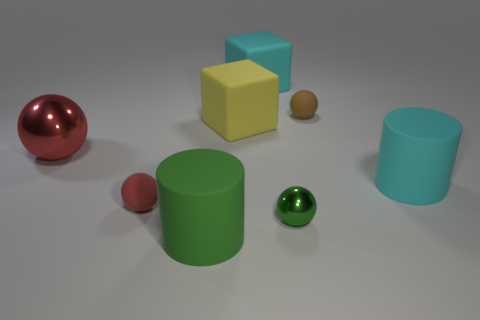Are there any other things that are the same color as the big ball?
Ensure brevity in your answer.  Yes. How many things are matte spheres that are in front of the big cyan rubber cylinder or big rubber cylinders that are right of the tiny brown thing?
Provide a short and direct response. 2. The object that is in front of the brown matte sphere and on the right side of the small metal ball has what shape?
Your answer should be very brief. Cylinder. There is a matte sphere that is in front of the brown matte thing; how many green objects are in front of it?
Provide a succinct answer. 2. Is there any other thing that is made of the same material as the tiny brown ball?
Provide a short and direct response. Yes. What number of objects are either large cyan rubber objects to the left of the green sphere or small green metal objects?
Provide a succinct answer. 2. How big is the matte object left of the green matte thing?
Offer a very short reply. Small. What is the material of the big yellow object?
Your response must be concise. Rubber. The red thing that is in front of the shiny object that is left of the green matte thing is what shape?
Keep it short and to the point. Sphere. How many other things are the same shape as the big green thing?
Make the answer very short. 1. 